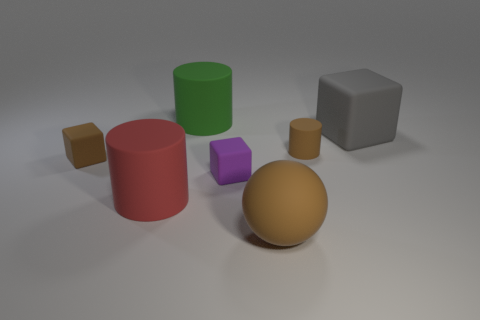There is a cylinder that is in front of the small rubber thing in front of the small cube to the left of the big red object; what is it made of?
Offer a terse response. Rubber. Are there more brown rubber objects behind the tiny brown cylinder than green rubber objects that are in front of the brown rubber block?
Offer a terse response. No. What number of matte things are either large cubes or tiny cubes?
Your answer should be compact. 3. What shape is the tiny thing that is the same color as the tiny rubber cylinder?
Keep it short and to the point. Cube. There is a brown thing left of the big red rubber cylinder; what is its material?
Your response must be concise. Rubber. What number of things are big matte objects or brown rubber objects that are behind the large red cylinder?
Keep it short and to the point. 6. There is a green rubber thing that is the same size as the red rubber cylinder; what is its shape?
Offer a very short reply. Cylinder. How many matte blocks have the same color as the large ball?
Keep it short and to the point. 1. Does the block behind the brown cylinder have the same material as the brown cylinder?
Offer a very short reply. Yes. There is a red rubber thing; what shape is it?
Ensure brevity in your answer.  Cylinder. 